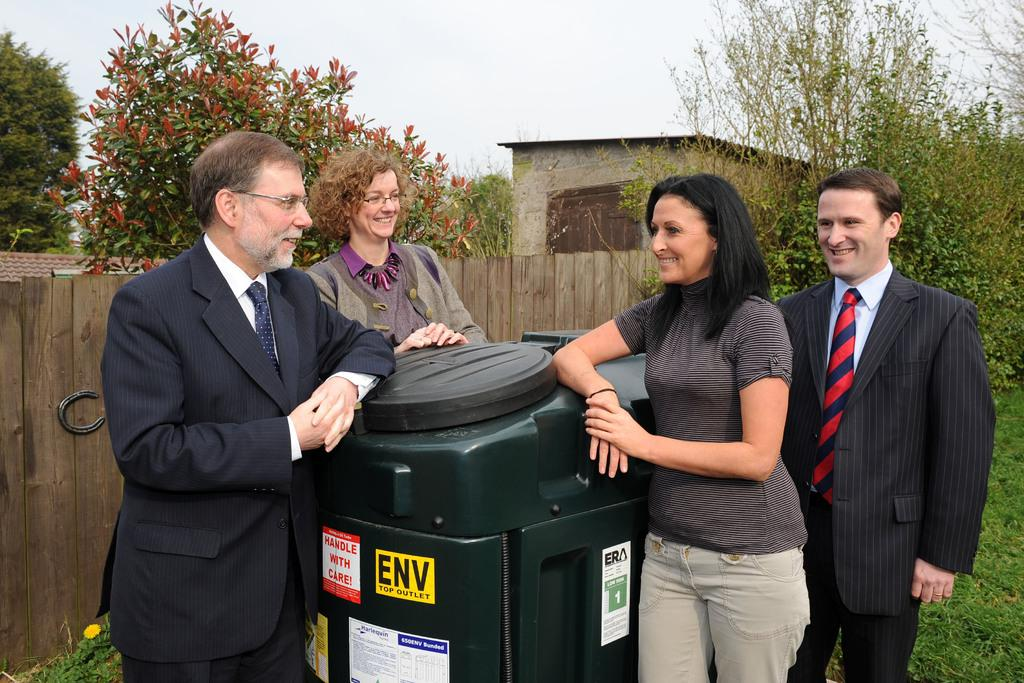Provide a one-sentence caption for the provided image. Four adults sit around a container with a sticker ENV TOP OUTLET. 